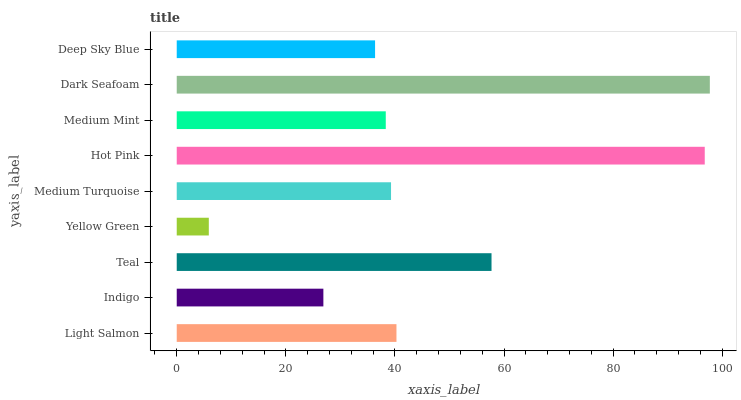Is Yellow Green the minimum?
Answer yes or no. Yes. Is Dark Seafoam the maximum?
Answer yes or no. Yes. Is Indigo the minimum?
Answer yes or no. No. Is Indigo the maximum?
Answer yes or no. No. Is Light Salmon greater than Indigo?
Answer yes or no. Yes. Is Indigo less than Light Salmon?
Answer yes or no. Yes. Is Indigo greater than Light Salmon?
Answer yes or no. No. Is Light Salmon less than Indigo?
Answer yes or no. No. Is Medium Turquoise the high median?
Answer yes or no. Yes. Is Medium Turquoise the low median?
Answer yes or no. Yes. Is Dark Seafoam the high median?
Answer yes or no. No. Is Deep Sky Blue the low median?
Answer yes or no. No. 